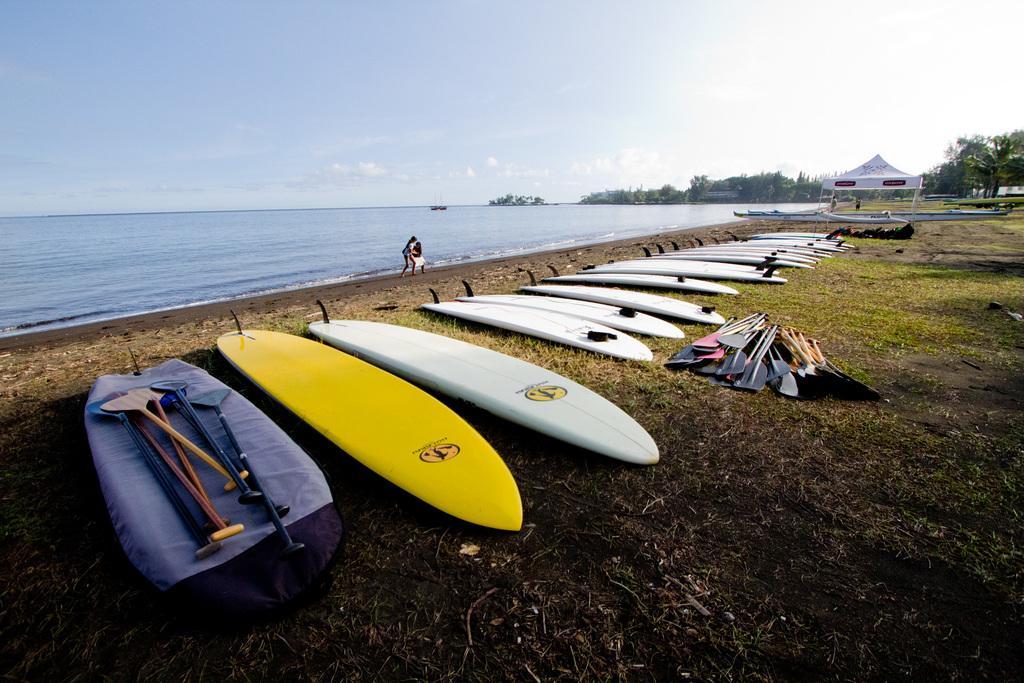How would you summarize this image in a sentence or two? In this image there are so many surf boards and paddles on the grass ground, beside them there is a tent and trees, also there is a beach and few people walking at the seashore. 